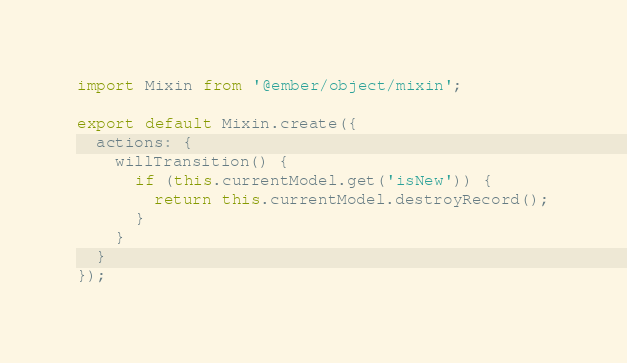Convert code to text. <code><loc_0><loc_0><loc_500><loc_500><_JavaScript_>import Mixin from '@ember/object/mixin';

export default Mixin.create({
  actions: {
    willTransition() {
      if (this.currentModel.get('isNew')) {
        return this.currentModel.destroyRecord();
      }
    }
  }
});
</code> 